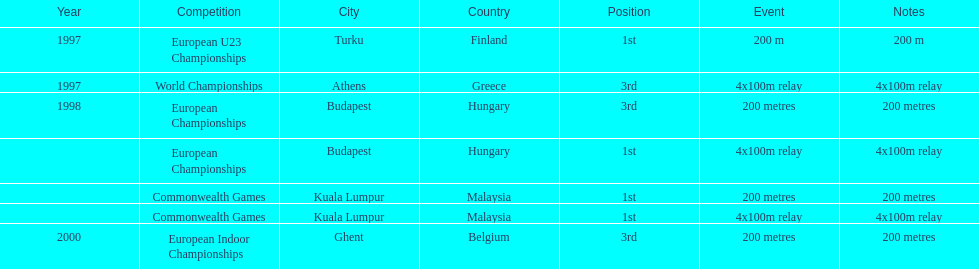In what year did england get the top achievment in the 200 meter? 1997. 